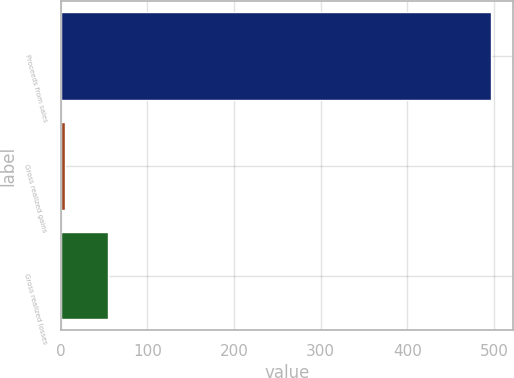Convert chart to OTSL. <chart><loc_0><loc_0><loc_500><loc_500><bar_chart><fcel>Proceeds from sales<fcel>Gross realized gains<fcel>Gross realized losses<nl><fcel>497<fcel>5<fcel>54.2<nl></chart> 